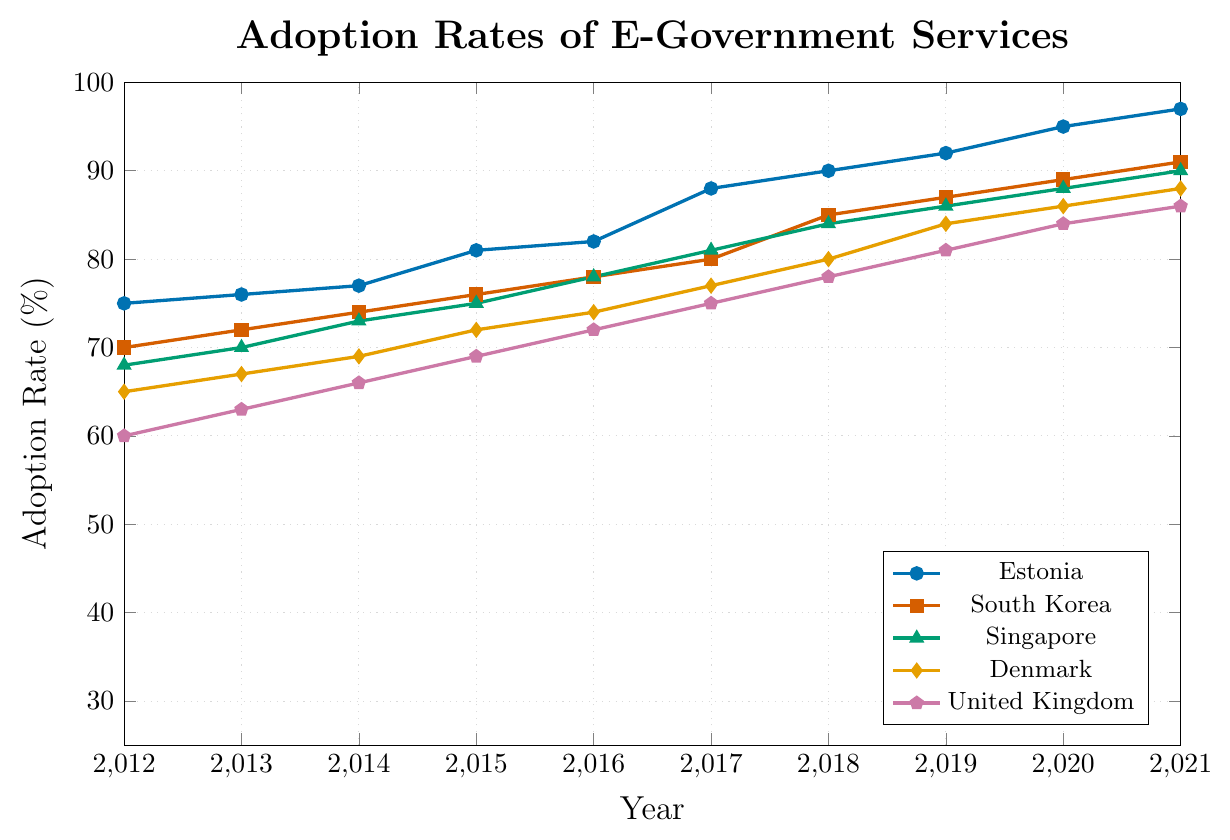Which country had the highest adoption rate of e-government services in 2021? To answer this, we look at the adoption rates for all listed countries in 2021 and see which one is the highest. Estonia has an adoption rate of 97%, which is the highest in the plotted data.
Answer: Estonia Which country showed the largest increase in adoption rate from 2012 to 2021? To determine this, calculate the difference between 2021 and 2012 adoption rates for each country and identify the largest value. Estonia went from 75% to 97%, a 22% increase, which is the largest.
Answer: Estonia What is the average adoption rate of e-government services in South Korea from 2012 to 2021? Add the adoption rates of South Korea from 2012 to 2021 and divide by the number of years. The sum is 79 + 80 + 74 + 75 + 78 + 80 + 85 + 87 + 89 + 91 = 811, and 811 divided by 10 is 81.1%
Answer: 81.1% Compare the adoption rates of e-government services between Denmark and the United Kingdom in 2017. Which country had a higher rate? Look at the adoption rates for Denmark and the United Kingdom in 2017. Denmark had a rate of 77%, while the United Kingdom had 75%. Hence, Denmark had a higher rate.
Answer: Denmark Which country had the lowest adoption rate of e-government services in 2012? Scan through the 2012 adoption rates for all countries to find the smallest value. South Africa had the lowest rate at 28%.
Answer: South Africa How many countries had an adoption rate of e-government services above 80% in 2021? Count the number of countries whose adoption rates in 2021 are above 80%. Estonia, South Korea, Singapore, Denmark, United Kingdom, United States, Canada, and Australia meet this criteria, making a total of 8.
Answer: 8 What was the median adoption rate of e-government services across the countries in 2015? First, list the 2015 adoption rates in ascending order (49, 50, 53, 55, 57, 59, 61, 64, 65, 67, 69, 72, 75, 76, 81). There are 17 values, so the median is the 9th value, which is 64%.
Answer: 64% Between 2015 and 2016, which country showed no increase in the adoption rate of e-government services? Compare the adoption rates for 2015 and 2016. All countries show an increase in the adoption rate, no country has zero increase.
Answer: None By how much did the adoption rate of e-government services in the United States increase from 2019 to 2021? Calculate the difference between 2021 and 2019 adoption rates for the United States. 2021 rate is 83%, and 2019 rate is 77%. So, the difference is 83 - 77 = 6%.
Answer: 6% What trend do we observe in the adoption rates of e-government services in Estonia over the past decade? By examining the year-over-year rates, it is clear that Estonia has shown a consistent upward trend from 75% in 2012 to 97% in 2021.
Answer: Increasing 